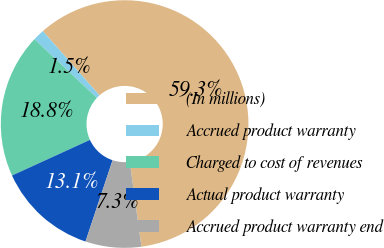Convert chart to OTSL. <chart><loc_0><loc_0><loc_500><loc_500><pie_chart><fcel>(In millions)<fcel>Accrued product warranty<fcel>Charged to cost of revenues<fcel>Actual product warranty<fcel>Accrued product warranty end<nl><fcel>59.31%<fcel>1.5%<fcel>18.84%<fcel>13.06%<fcel>7.28%<nl></chart> 